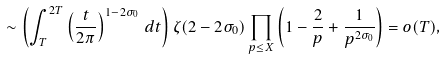<formula> <loc_0><loc_0><loc_500><loc_500>& \sim \left ( \int _ { T } ^ { 2 T } \left ( \frac { t } { 2 \pi } \right ) ^ { 1 - 2 \sigma _ { 0 } } \, d t \right ) \zeta ( 2 - 2 \sigma _ { 0 } ) \prod _ { p \leq X } \left ( 1 - \frac { 2 } { p } + \frac { 1 } { p ^ { 2 \sigma _ { 0 } } } \right ) = o ( T ) ,</formula> 